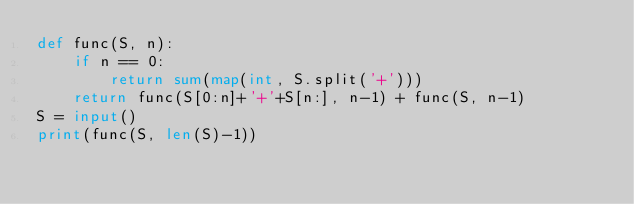Convert code to text. <code><loc_0><loc_0><loc_500><loc_500><_Python_>def func(S, n):
    if n == 0:
        return sum(map(int, S.split('+')))
    return func(S[0:n]+'+'+S[n:], n-1) + func(S, n-1)
S = input()
print(func(S, len(S)-1))</code> 